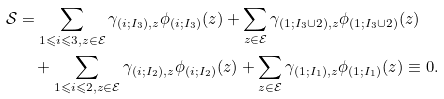<formula> <loc_0><loc_0><loc_500><loc_500>\mathcal { S } & = \sum _ { 1 \leqslant i \leqslant 3 , z \in \mathcal { E } } \gamma _ { ( i ; I _ { 3 } ) , z } \phi _ { ( i ; I _ { 3 } ) } ( z ) + \sum _ { z \in \mathcal { E } } \gamma _ { ( 1 ; I _ { 3 } \cup 2 ) , z } \phi _ { ( 1 ; I _ { 3 } \cup 2 ) } ( z ) \\ & \quad + \sum _ { 1 \leqslant i \leqslant 2 , z \in \mathcal { E } } \gamma _ { ( i ; I _ { 2 } ) , z } \phi _ { ( i ; I _ { 2 } ) } ( z ) + \sum _ { z \in \mathcal { E } } \gamma _ { ( 1 ; I _ { 1 } ) , z } \phi _ { ( 1 ; I _ { 1 } ) } ( z ) \equiv 0 .</formula> 